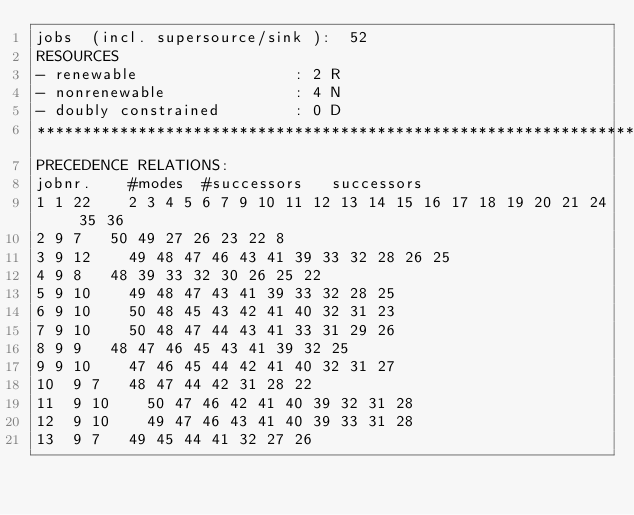<code> <loc_0><loc_0><loc_500><loc_500><_ObjectiveC_>jobs  (incl. supersource/sink ):	52
RESOURCES
- renewable                 : 2 R
- nonrenewable              : 4 N
- doubly constrained        : 0 D
************************************************************************
PRECEDENCE RELATIONS:
jobnr.    #modes  #successors   successors
1	1	22		2 3 4 5 6 7 9 10 11 12 13 14 15 16 17 18 19 20 21 24 35 36 
2	9	7		50 49 27 26 23 22 8 
3	9	12		49 48 47 46 43 41 39 33 32 28 26 25 
4	9	8		48 39 33 32 30 26 25 22 
5	9	10		49 48 47 43 41 39 33 32 28 25 
6	9	10		50 48 45 43 42 41 40 32 31 23 
7	9	10		50 48 47 44 43 41 33 31 29 26 
8	9	9		48 47 46 45 43 41 39 32 25 
9	9	10		47 46 45 44 42 41 40 32 31 27 
10	9	7		48 47 44 42 31 28 22 
11	9	10		50 47 46 42 41 40 39 32 31 28 
12	9	10		49 47 46 43 41 40 39 33 31 28 
13	9	7		49 45 44 41 32 27 26 </code> 